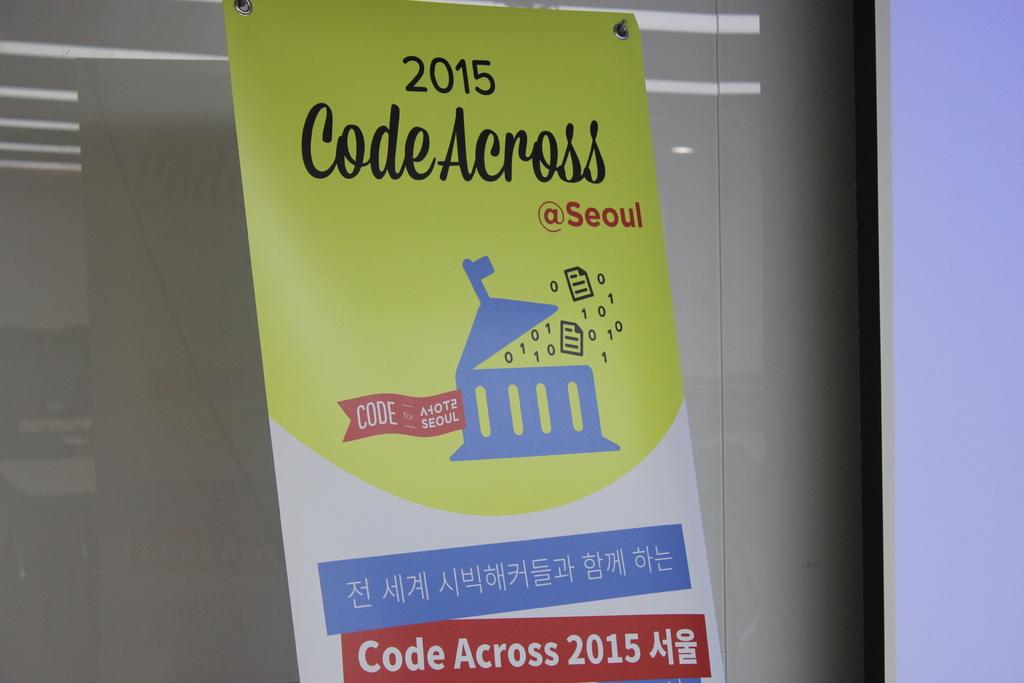<image>
Share a concise interpretation of the image provided. A poster is labeled "2015 Code Across @ Seoul". 